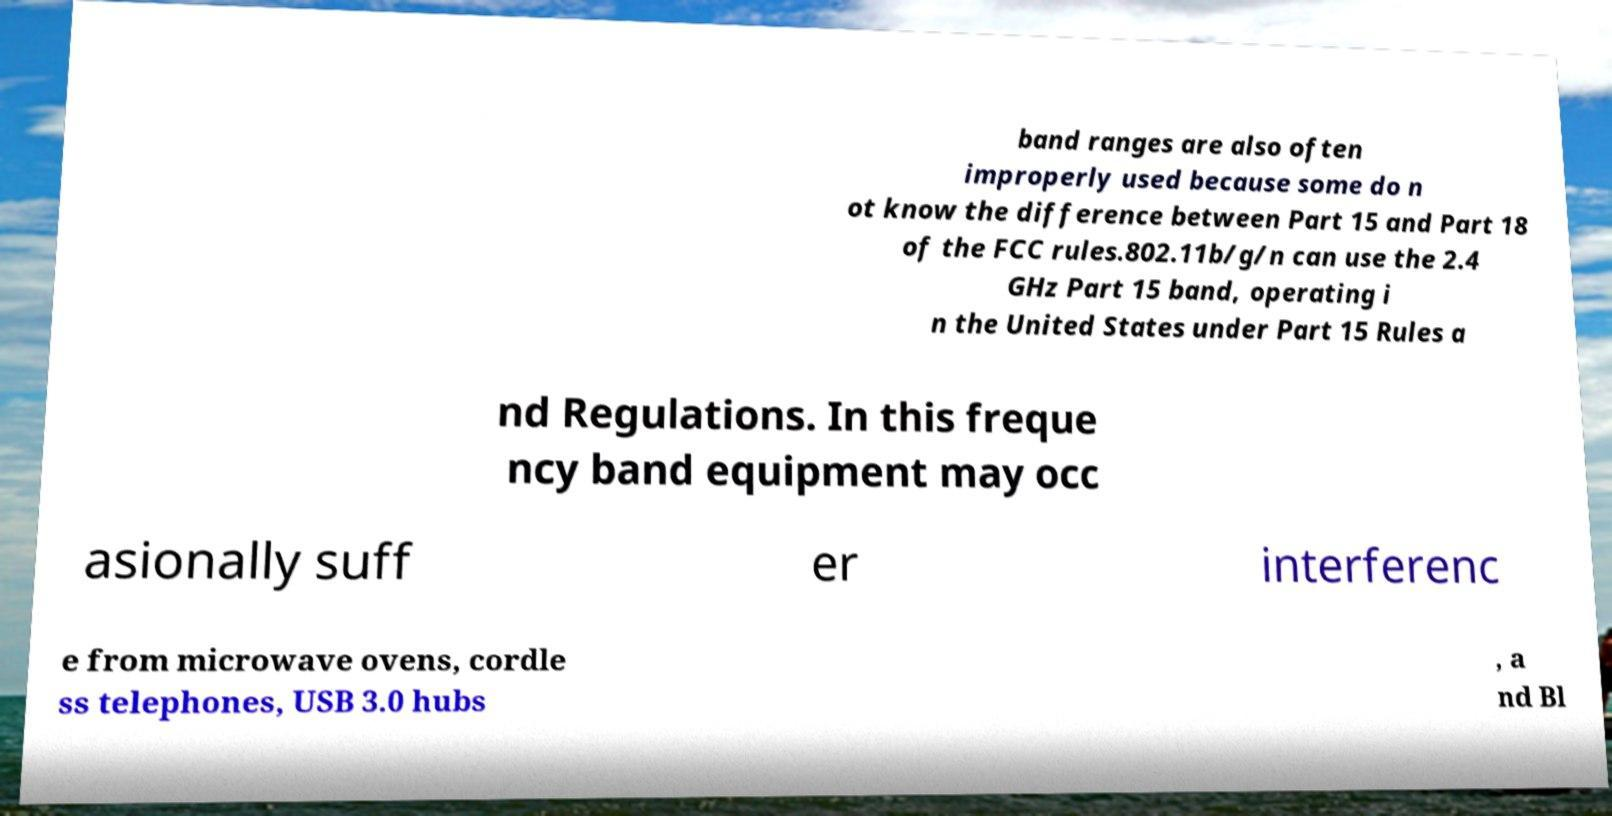Can you accurately transcribe the text from the provided image for me? band ranges are also often improperly used because some do n ot know the difference between Part 15 and Part 18 of the FCC rules.802.11b/g/n can use the 2.4 GHz Part 15 band, operating i n the United States under Part 15 Rules a nd Regulations. In this freque ncy band equipment may occ asionally suff er interferenc e from microwave ovens, cordle ss telephones, USB 3.0 hubs , a nd Bl 